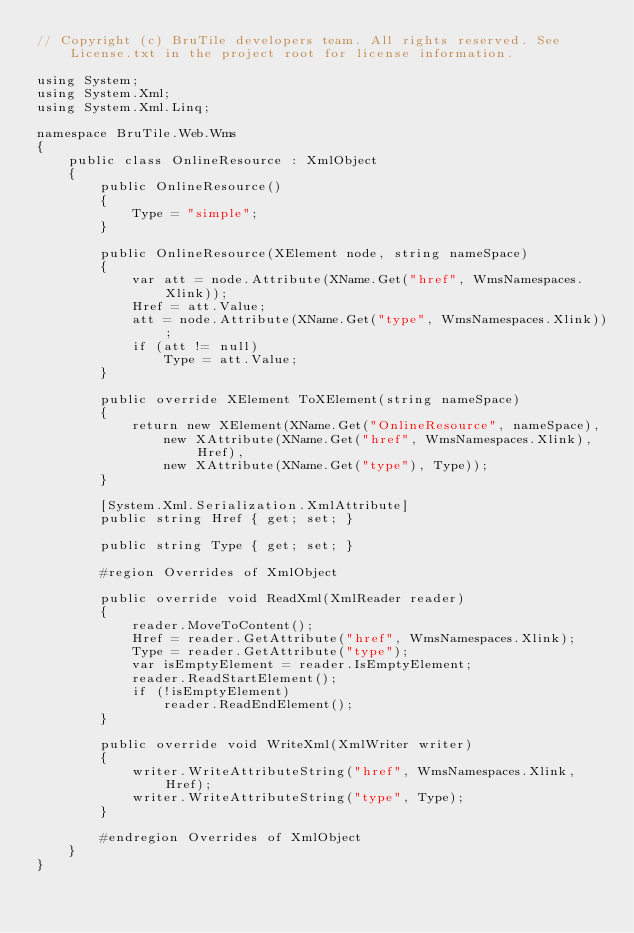<code> <loc_0><loc_0><loc_500><loc_500><_C#_>// Copyright (c) BruTile developers team. All rights reserved. See License.txt in the project root for license information.

using System;
using System.Xml;
using System.Xml.Linq;

namespace BruTile.Web.Wms
{
    public class OnlineResource : XmlObject
    {
        public OnlineResource()
        {
            Type = "simple";
        }

        public OnlineResource(XElement node, string nameSpace)
        {
            var att = node.Attribute(XName.Get("href", WmsNamespaces.Xlink));
            Href = att.Value;
            att = node.Attribute(XName.Get("type", WmsNamespaces.Xlink));
            if (att != null)
                Type = att.Value;
        }

        public override XElement ToXElement(string nameSpace)
        {
            return new XElement(XName.Get("OnlineResource", nameSpace),
                new XAttribute(XName.Get("href", WmsNamespaces.Xlink), Href),
                new XAttribute(XName.Get("type"), Type));
        }

        [System.Xml.Serialization.XmlAttribute]
        public string Href { get; set; }

        public string Type { get; set; }

        #region Overrides of XmlObject

        public override void ReadXml(XmlReader reader)
        {
            reader.MoveToContent();
            Href = reader.GetAttribute("href", WmsNamespaces.Xlink);
            Type = reader.GetAttribute("type");
            var isEmptyElement = reader.IsEmptyElement;
            reader.ReadStartElement();
            if (!isEmptyElement)
                reader.ReadEndElement();
        }

        public override void WriteXml(XmlWriter writer)
        {
            writer.WriteAttributeString("href", WmsNamespaces.Xlink, Href);
            writer.WriteAttributeString("type", Type);
        }

        #endregion Overrides of XmlObject
    }
}</code> 